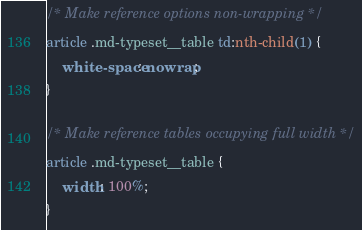Convert code to text. <code><loc_0><loc_0><loc_500><loc_500><_CSS_>
/* Make reference options non-wrapping */
article .md-typeset__table td:nth-child(1) {
    white-space: nowrap;
}

/* Make reference tables occupying full width */
article .md-typeset__table {
    width: 100%;
}
</code> 